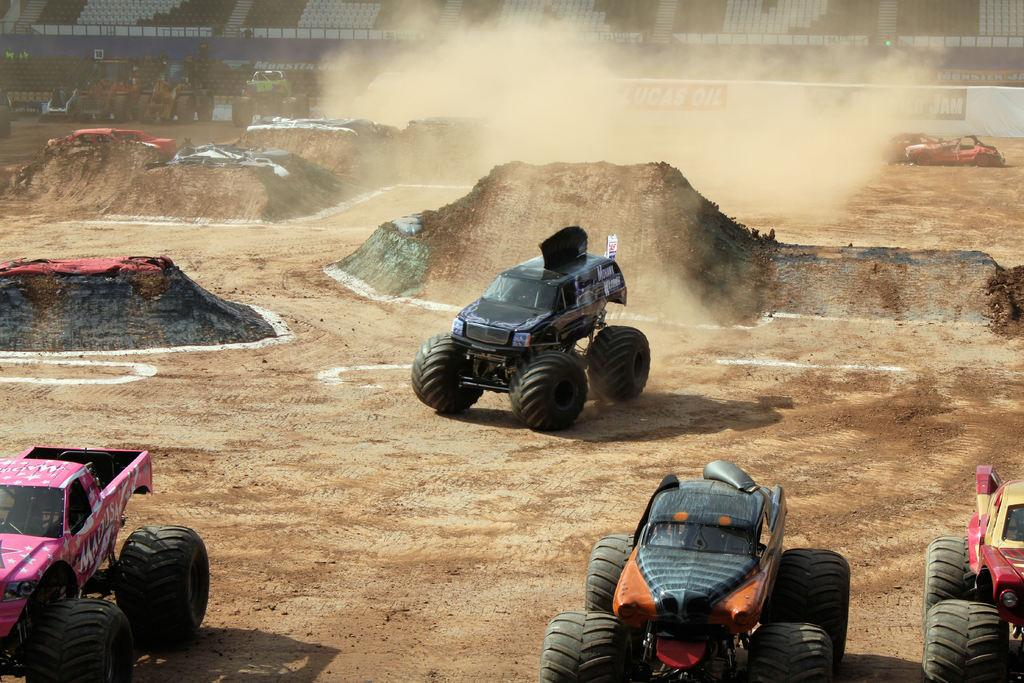What is the main subject of the image? The main subject of the image is many vehicles. Where are the vehicles located in relation to the land? The vehicles are around a land in the image. What can be seen behind the land? There are empty chairs behind the land. Can you see a snake slithering down a slope near the sea in the image? There is no snake or sea present in the image; it features many vehicles around a land with empty chairs behind it. 